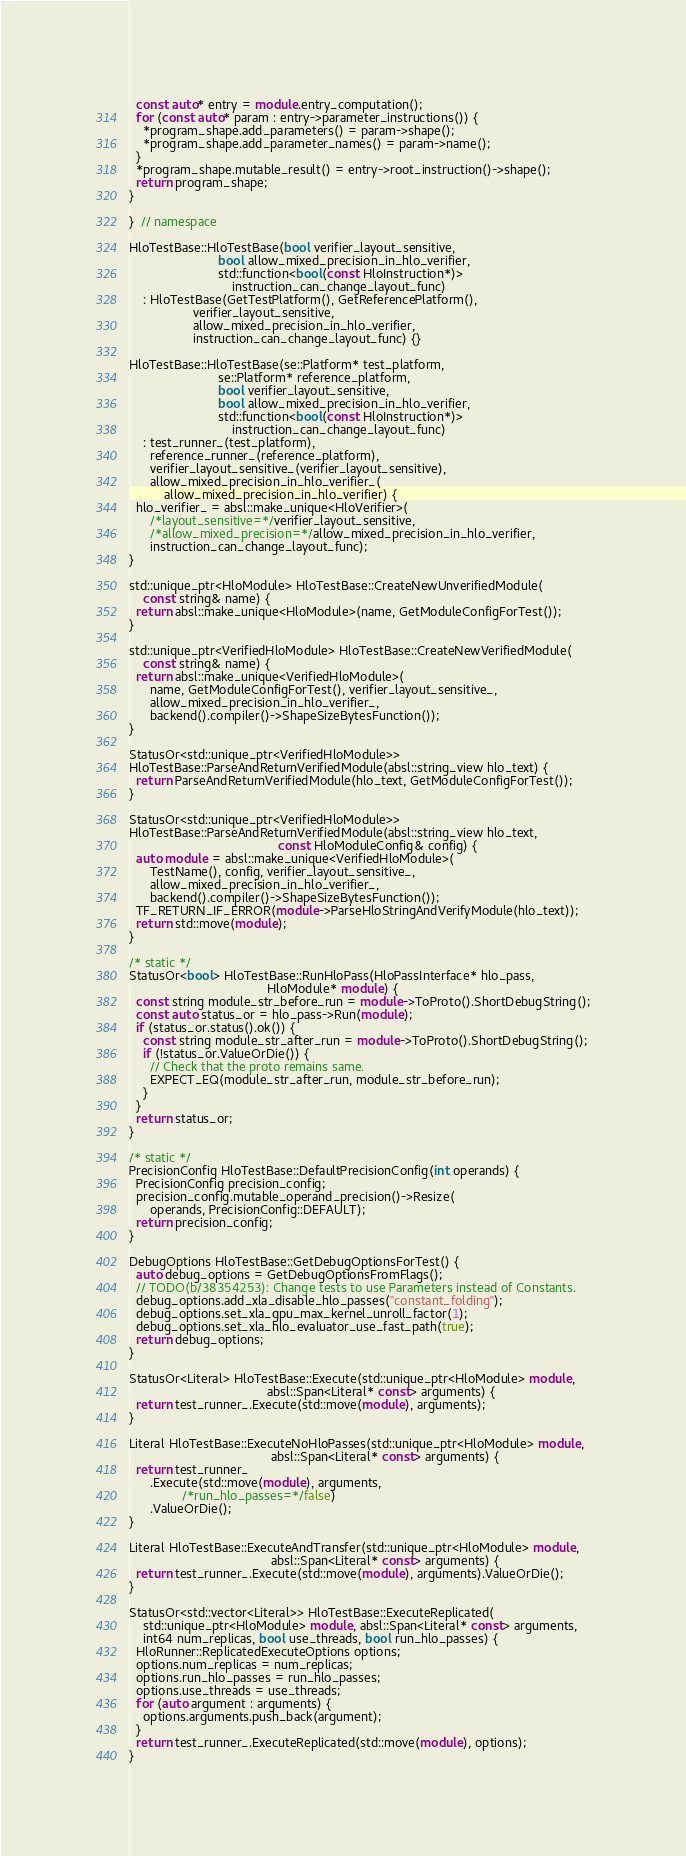Convert code to text. <code><loc_0><loc_0><loc_500><loc_500><_C++_>  const auto* entry = module.entry_computation();
  for (const auto* param : entry->parameter_instructions()) {
    *program_shape.add_parameters() = param->shape();
    *program_shape.add_parameter_names() = param->name();
  }
  *program_shape.mutable_result() = entry->root_instruction()->shape();
  return program_shape;
}

}  // namespace

HloTestBase::HloTestBase(bool verifier_layout_sensitive,
                         bool allow_mixed_precision_in_hlo_verifier,
                         std::function<bool(const HloInstruction*)>
                             instruction_can_change_layout_func)
    : HloTestBase(GetTestPlatform(), GetReferencePlatform(),
                  verifier_layout_sensitive,
                  allow_mixed_precision_in_hlo_verifier,
                  instruction_can_change_layout_func) {}

HloTestBase::HloTestBase(se::Platform* test_platform,
                         se::Platform* reference_platform,
                         bool verifier_layout_sensitive,
                         bool allow_mixed_precision_in_hlo_verifier,
                         std::function<bool(const HloInstruction*)>
                             instruction_can_change_layout_func)
    : test_runner_(test_platform),
      reference_runner_(reference_platform),
      verifier_layout_sensitive_(verifier_layout_sensitive),
      allow_mixed_precision_in_hlo_verifier_(
          allow_mixed_precision_in_hlo_verifier) {
  hlo_verifier_ = absl::make_unique<HloVerifier>(
      /*layout_sensitive=*/verifier_layout_sensitive,
      /*allow_mixed_precision=*/allow_mixed_precision_in_hlo_verifier,
      instruction_can_change_layout_func);
}

std::unique_ptr<HloModule> HloTestBase::CreateNewUnverifiedModule(
    const string& name) {
  return absl::make_unique<HloModule>(name, GetModuleConfigForTest());
}

std::unique_ptr<VerifiedHloModule> HloTestBase::CreateNewVerifiedModule(
    const string& name) {
  return absl::make_unique<VerifiedHloModule>(
      name, GetModuleConfigForTest(), verifier_layout_sensitive_,
      allow_mixed_precision_in_hlo_verifier_,
      backend().compiler()->ShapeSizeBytesFunction());
}

StatusOr<std::unique_ptr<VerifiedHloModule>>
HloTestBase::ParseAndReturnVerifiedModule(absl::string_view hlo_text) {
  return ParseAndReturnVerifiedModule(hlo_text, GetModuleConfigForTest());
}

StatusOr<std::unique_ptr<VerifiedHloModule>>
HloTestBase::ParseAndReturnVerifiedModule(absl::string_view hlo_text,
                                          const HloModuleConfig& config) {
  auto module = absl::make_unique<VerifiedHloModule>(
      TestName(), config, verifier_layout_sensitive_,
      allow_mixed_precision_in_hlo_verifier_,
      backend().compiler()->ShapeSizeBytesFunction());
  TF_RETURN_IF_ERROR(module->ParseHloStringAndVerifyModule(hlo_text));
  return std::move(module);
}

/* static */
StatusOr<bool> HloTestBase::RunHloPass(HloPassInterface* hlo_pass,
                                       HloModule* module) {
  const string module_str_before_run = module->ToProto().ShortDebugString();
  const auto status_or = hlo_pass->Run(module);
  if (status_or.status().ok()) {
    const string module_str_after_run = module->ToProto().ShortDebugString();
    if (!status_or.ValueOrDie()) {
      // Check that the proto remains same.
      EXPECT_EQ(module_str_after_run, module_str_before_run);
    }
  }
  return status_or;
}

/* static */
PrecisionConfig HloTestBase::DefaultPrecisionConfig(int operands) {
  PrecisionConfig precision_config;
  precision_config.mutable_operand_precision()->Resize(
      operands, PrecisionConfig::DEFAULT);
  return precision_config;
}

DebugOptions HloTestBase::GetDebugOptionsForTest() {
  auto debug_options = GetDebugOptionsFromFlags();
  // TODO(b/38354253): Change tests to use Parameters instead of Constants.
  debug_options.add_xla_disable_hlo_passes("constant_folding");
  debug_options.set_xla_gpu_max_kernel_unroll_factor(1);
  debug_options.set_xla_hlo_evaluator_use_fast_path(true);
  return debug_options;
}

StatusOr<Literal> HloTestBase::Execute(std::unique_ptr<HloModule> module,
                                       absl::Span<Literal* const> arguments) {
  return test_runner_.Execute(std::move(module), arguments);
}

Literal HloTestBase::ExecuteNoHloPasses(std::unique_ptr<HloModule> module,
                                        absl::Span<Literal* const> arguments) {
  return test_runner_
      .Execute(std::move(module), arguments,
               /*run_hlo_passes=*/false)
      .ValueOrDie();
}

Literal HloTestBase::ExecuteAndTransfer(std::unique_ptr<HloModule> module,
                                        absl::Span<Literal* const> arguments) {
  return test_runner_.Execute(std::move(module), arguments).ValueOrDie();
}

StatusOr<std::vector<Literal>> HloTestBase::ExecuteReplicated(
    std::unique_ptr<HloModule> module, absl::Span<Literal* const> arguments,
    int64 num_replicas, bool use_threads, bool run_hlo_passes) {
  HloRunner::ReplicatedExecuteOptions options;
  options.num_replicas = num_replicas;
  options.run_hlo_passes = run_hlo_passes;
  options.use_threads = use_threads;
  for (auto argument : arguments) {
    options.arguments.push_back(argument);
  }
  return test_runner_.ExecuteReplicated(std::move(module), options);
}
</code> 